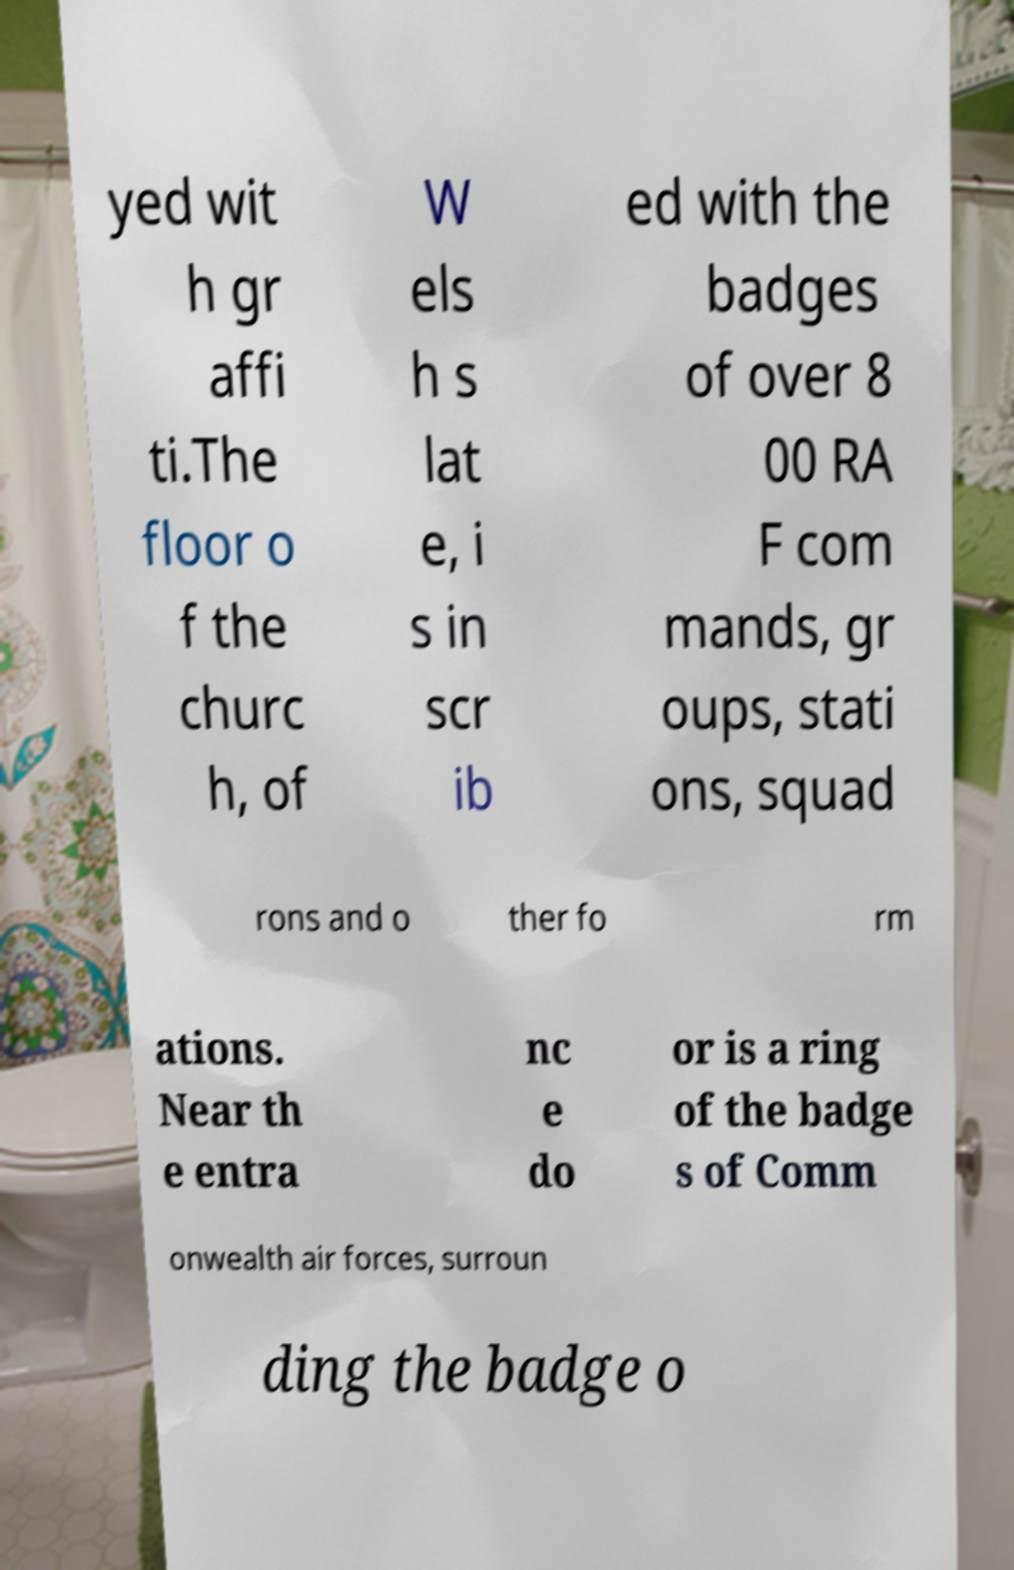I need the written content from this picture converted into text. Can you do that? yed wit h gr affi ti.The floor o f the churc h, of W els h s lat e, i s in scr ib ed with the badges of over 8 00 RA F com mands, gr oups, stati ons, squad rons and o ther fo rm ations. Near th e entra nc e do or is a ring of the badge s of Comm onwealth air forces, surroun ding the badge o 